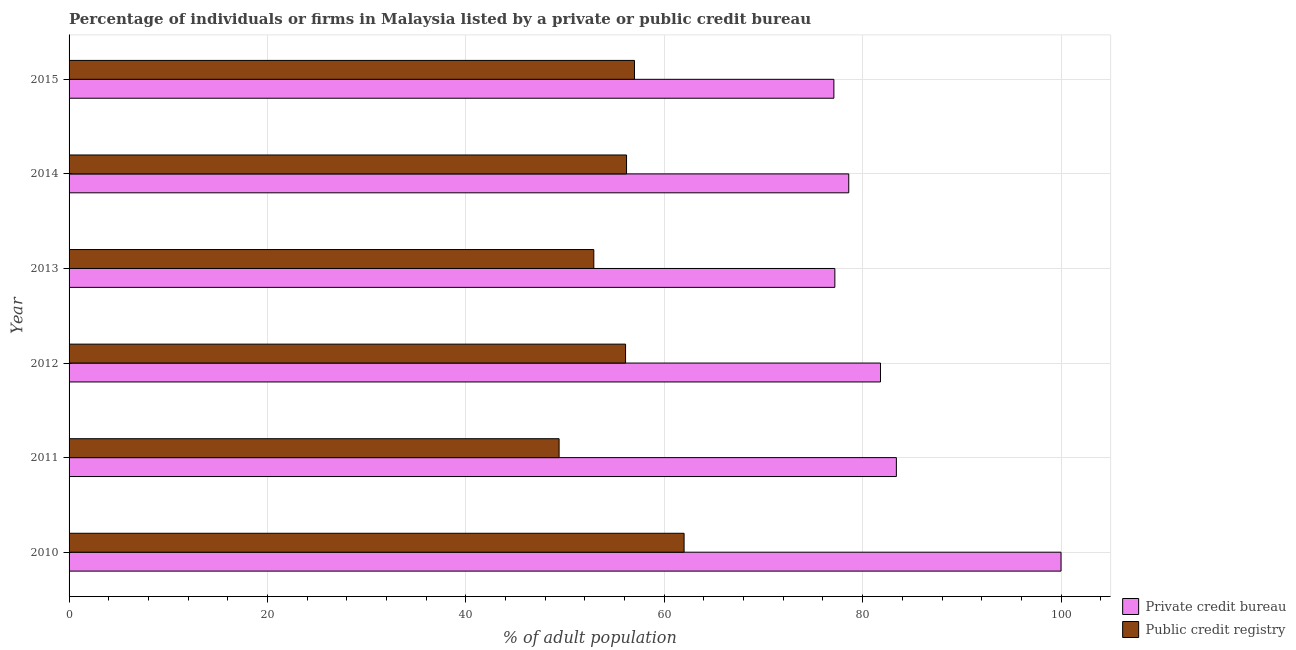How many groups of bars are there?
Give a very brief answer. 6. Are the number of bars on each tick of the Y-axis equal?
Provide a succinct answer. Yes. How many bars are there on the 5th tick from the bottom?
Provide a succinct answer. 2. What is the percentage of firms listed by public credit bureau in 2011?
Provide a short and direct response. 49.4. Across all years, what is the minimum percentage of firms listed by public credit bureau?
Your response must be concise. 49.4. In which year was the percentage of firms listed by public credit bureau minimum?
Keep it short and to the point. 2011. What is the total percentage of firms listed by public credit bureau in the graph?
Offer a terse response. 333.6. What is the difference between the percentage of firms listed by private credit bureau in 2011 and that in 2014?
Ensure brevity in your answer.  4.8. What is the difference between the percentage of firms listed by public credit bureau in 2012 and the percentage of firms listed by private credit bureau in 2010?
Provide a succinct answer. -43.9. What is the average percentage of firms listed by private credit bureau per year?
Provide a short and direct response. 83.02. In the year 2013, what is the difference between the percentage of firms listed by public credit bureau and percentage of firms listed by private credit bureau?
Offer a terse response. -24.3. In how many years, is the percentage of firms listed by private credit bureau greater than 76 %?
Keep it short and to the point. 6. What is the ratio of the percentage of firms listed by private credit bureau in 2011 to that in 2014?
Ensure brevity in your answer.  1.06. Is the percentage of firms listed by public credit bureau in 2010 less than that in 2011?
Give a very brief answer. No. What is the difference between the highest and the lowest percentage of firms listed by public credit bureau?
Offer a terse response. 12.6. Is the sum of the percentage of firms listed by private credit bureau in 2010 and 2013 greater than the maximum percentage of firms listed by public credit bureau across all years?
Make the answer very short. Yes. What does the 1st bar from the top in 2015 represents?
Your response must be concise. Public credit registry. What does the 2nd bar from the bottom in 2015 represents?
Provide a short and direct response. Public credit registry. How many bars are there?
Provide a succinct answer. 12. Does the graph contain any zero values?
Your response must be concise. No. What is the title of the graph?
Keep it short and to the point. Percentage of individuals or firms in Malaysia listed by a private or public credit bureau. What is the label or title of the X-axis?
Give a very brief answer. % of adult population. What is the label or title of the Y-axis?
Provide a short and direct response. Year. What is the % of adult population in Private credit bureau in 2011?
Offer a terse response. 83.4. What is the % of adult population in Public credit registry in 2011?
Provide a short and direct response. 49.4. What is the % of adult population of Private credit bureau in 2012?
Offer a terse response. 81.8. What is the % of adult population in Public credit registry in 2012?
Your answer should be compact. 56.1. What is the % of adult population of Private credit bureau in 2013?
Your answer should be compact. 77.2. What is the % of adult population in Public credit registry in 2013?
Make the answer very short. 52.9. What is the % of adult population in Private credit bureau in 2014?
Provide a succinct answer. 78.6. What is the % of adult population in Public credit registry in 2014?
Offer a terse response. 56.2. What is the % of adult population in Private credit bureau in 2015?
Your answer should be very brief. 77.1. What is the % of adult population in Public credit registry in 2015?
Provide a succinct answer. 57. Across all years, what is the minimum % of adult population in Private credit bureau?
Your response must be concise. 77.1. Across all years, what is the minimum % of adult population in Public credit registry?
Ensure brevity in your answer.  49.4. What is the total % of adult population of Private credit bureau in the graph?
Give a very brief answer. 498.1. What is the total % of adult population in Public credit registry in the graph?
Your answer should be very brief. 333.6. What is the difference between the % of adult population of Private credit bureau in 2010 and that in 2012?
Give a very brief answer. 18.2. What is the difference between the % of adult population in Public credit registry in 2010 and that in 2012?
Make the answer very short. 5.9. What is the difference between the % of adult population of Private credit bureau in 2010 and that in 2013?
Your answer should be compact. 22.8. What is the difference between the % of adult population in Private credit bureau in 2010 and that in 2014?
Keep it short and to the point. 21.4. What is the difference between the % of adult population in Private credit bureau in 2010 and that in 2015?
Offer a terse response. 22.9. What is the difference between the % of adult population in Public credit registry in 2010 and that in 2015?
Keep it short and to the point. 5. What is the difference between the % of adult population in Public credit registry in 2011 and that in 2013?
Give a very brief answer. -3.5. What is the difference between the % of adult population in Private credit bureau in 2011 and that in 2014?
Ensure brevity in your answer.  4.8. What is the difference between the % of adult population in Private credit bureau in 2011 and that in 2015?
Ensure brevity in your answer.  6.3. What is the difference between the % of adult population in Public credit registry in 2012 and that in 2013?
Your response must be concise. 3.2. What is the difference between the % of adult population in Public credit registry in 2012 and that in 2014?
Provide a short and direct response. -0.1. What is the difference between the % of adult population of Private credit bureau in 2012 and that in 2015?
Ensure brevity in your answer.  4.7. What is the difference between the % of adult population of Private credit bureau in 2013 and that in 2014?
Give a very brief answer. -1.4. What is the difference between the % of adult population of Public credit registry in 2013 and that in 2014?
Provide a short and direct response. -3.3. What is the difference between the % of adult population in Private credit bureau in 2013 and that in 2015?
Give a very brief answer. 0.1. What is the difference between the % of adult population in Public credit registry in 2013 and that in 2015?
Give a very brief answer. -4.1. What is the difference between the % of adult population in Private credit bureau in 2010 and the % of adult population in Public credit registry in 2011?
Your answer should be very brief. 50.6. What is the difference between the % of adult population in Private credit bureau in 2010 and the % of adult population in Public credit registry in 2012?
Your response must be concise. 43.9. What is the difference between the % of adult population of Private credit bureau in 2010 and the % of adult population of Public credit registry in 2013?
Your response must be concise. 47.1. What is the difference between the % of adult population of Private credit bureau in 2010 and the % of adult population of Public credit registry in 2014?
Your answer should be compact. 43.8. What is the difference between the % of adult population of Private credit bureau in 2011 and the % of adult population of Public credit registry in 2012?
Provide a succinct answer. 27.3. What is the difference between the % of adult population of Private credit bureau in 2011 and the % of adult population of Public credit registry in 2013?
Your answer should be compact. 30.5. What is the difference between the % of adult population of Private credit bureau in 2011 and the % of adult population of Public credit registry in 2014?
Your answer should be compact. 27.2. What is the difference between the % of adult population of Private credit bureau in 2011 and the % of adult population of Public credit registry in 2015?
Ensure brevity in your answer.  26.4. What is the difference between the % of adult population of Private credit bureau in 2012 and the % of adult population of Public credit registry in 2013?
Offer a very short reply. 28.9. What is the difference between the % of adult population in Private credit bureau in 2012 and the % of adult population in Public credit registry in 2014?
Ensure brevity in your answer.  25.6. What is the difference between the % of adult population in Private credit bureau in 2012 and the % of adult population in Public credit registry in 2015?
Ensure brevity in your answer.  24.8. What is the difference between the % of adult population in Private credit bureau in 2013 and the % of adult population in Public credit registry in 2014?
Give a very brief answer. 21. What is the difference between the % of adult population in Private credit bureau in 2013 and the % of adult population in Public credit registry in 2015?
Ensure brevity in your answer.  20.2. What is the difference between the % of adult population in Private credit bureau in 2014 and the % of adult population in Public credit registry in 2015?
Your response must be concise. 21.6. What is the average % of adult population of Private credit bureau per year?
Make the answer very short. 83.02. What is the average % of adult population in Public credit registry per year?
Keep it short and to the point. 55.6. In the year 2012, what is the difference between the % of adult population of Private credit bureau and % of adult population of Public credit registry?
Your answer should be very brief. 25.7. In the year 2013, what is the difference between the % of adult population of Private credit bureau and % of adult population of Public credit registry?
Keep it short and to the point. 24.3. In the year 2014, what is the difference between the % of adult population of Private credit bureau and % of adult population of Public credit registry?
Keep it short and to the point. 22.4. In the year 2015, what is the difference between the % of adult population of Private credit bureau and % of adult population of Public credit registry?
Make the answer very short. 20.1. What is the ratio of the % of adult population in Private credit bureau in 2010 to that in 2011?
Offer a very short reply. 1.2. What is the ratio of the % of adult population in Public credit registry in 2010 to that in 2011?
Your response must be concise. 1.26. What is the ratio of the % of adult population of Private credit bureau in 2010 to that in 2012?
Provide a succinct answer. 1.22. What is the ratio of the % of adult population in Public credit registry in 2010 to that in 2012?
Offer a terse response. 1.11. What is the ratio of the % of adult population of Private credit bureau in 2010 to that in 2013?
Keep it short and to the point. 1.3. What is the ratio of the % of adult population in Public credit registry in 2010 to that in 2013?
Your response must be concise. 1.17. What is the ratio of the % of adult population of Private credit bureau in 2010 to that in 2014?
Offer a terse response. 1.27. What is the ratio of the % of adult population of Public credit registry in 2010 to that in 2014?
Provide a succinct answer. 1.1. What is the ratio of the % of adult population in Private credit bureau in 2010 to that in 2015?
Provide a succinct answer. 1.3. What is the ratio of the % of adult population in Public credit registry in 2010 to that in 2015?
Your response must be concise. 1.09. What is the ratio of the % of adult population in Private credit bureau in 2011 to that in 2012?
Your response must be concise. 1.02. What is the ratio of the % of adult population of Public credit registry in 2011 to that in 2012?
Your response must be concise. 0.88. What is the ratio of the % of adult population in Private credit bureau in 2011 to that in 2013?
Your answer should be very brief. 1.08. What is the ratio of the % of adult population in Public credit registry in 2011 to that in 2013?
Keep it short and to the point. 0.93. What is the ratio of the % of adult population of Private credit bureau in 2011 to that in 2014?
Your answer should be compact. 1.06. What is the ratio of the % of adult population in Public credit registry in 2011 to that in 2014?
Provide a succinct answer. 0.88. What is the ratio of the % of adult population in Private credit bureau in 2011 to that in 2015?
Provide a succinct answer. 1.08. What is the ratio of the % of adult population in Public credit registry in 2011 to that in 2015?
Offer a very short reply. 0.87. What is the ratio of the % of adult population in Private credit bureau in 2012 to that in 2013?
Ensure brevity in your answer.  1.06. What is the ratio of the % of adult population of Public credit registry in 2012 to that in 2013?
Your answer should be compact. 1.06. What is the ratio of the % of adult population of Private credit bureau in 2012 to that in 2014?
Offer a terse response. 1.04. What is the ratio of the % of adult population in Public credit registry in 2012 to that in 2014?
Make the answer very short. 1. What is the ratio of the % of adult population in Private credit bureau in 2012 to that in 2015?
Your answer should be very brief. 1.06. What is the ratio of the % of adult population of Public credit registry in 2012 to that in 2015?
Give a very brief answer. 0.98. What is the ratio of the % of adult population of Private credit bureau in 2013 to that in 2014?
Your answer should be compact. 0.98. What is the ratio of the % of adult population in Public credit registry in 2013 to that in 2014?
Provide a short and direct response. 0.94. What is the ratio of the % of adult population in Private credit bureau in 2013 to that in 2015?
Keep it short and to the point. 1. What is the ratio of the % of adult population of Public credit registry in 2013 to that in 2015?
Ensure brevity in your answer.  0.93. What is the ratio of the % of adult population of Private credit bureau in 2014 to that in 2015?
Your answer should be very brief. 1.02. What is the ratio of the % of adult population of Public credit registry in 2014 to that in 2015?
Ensure brevity in your answer.  0.99. What is the difference between the highest and the second highest % of adult population of Private credit bureau?
Your answer should be very brief. 16.6. What is the difference between the highest and the lowest % of adult population in Private credit bureau?
Your answer should be very brief. 22.9. What is the difference between the highest and the lowest % of adult population of Public credit registry?
Your answer should be compact. 12.6. 